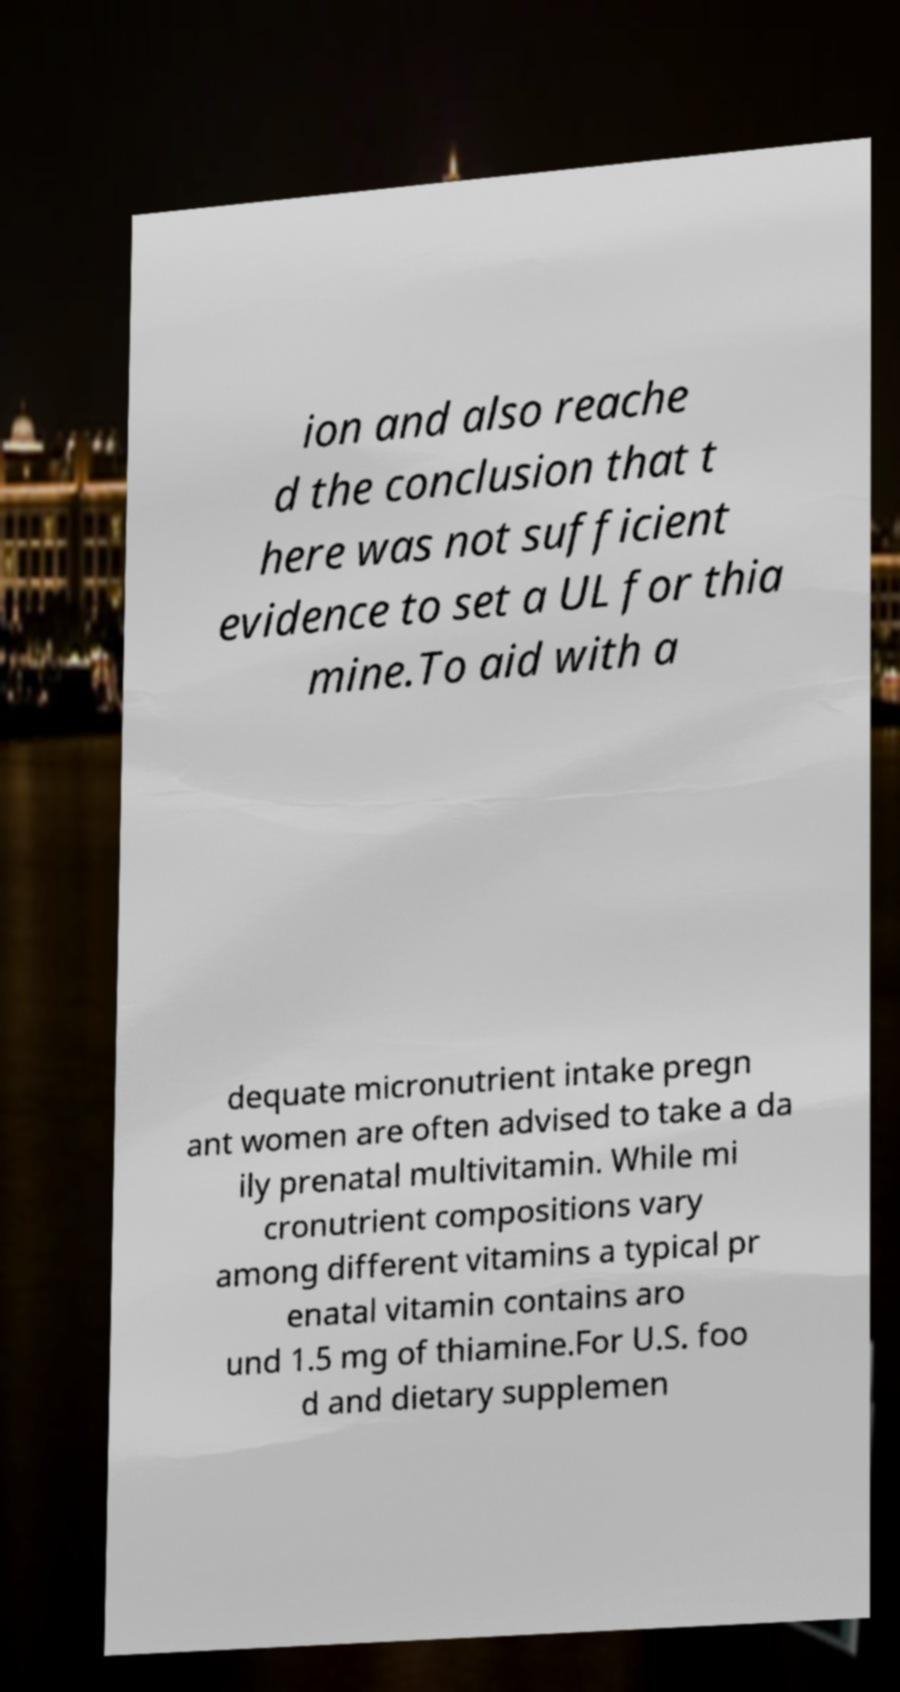For documentation purposes, I need the text within this image transcribed. Could you provide that? ion and also reache d the conclusion that t here was not sufficient evidence to set a UL for thia mine.To aid with a dequate micronutrient intake pregn ant women are often advised to take a da ily prenatal multivitamin. While mi cronutrient compositions vary among different vitamins a typical pr enatal vitamin contains aro und 1.5 mg of thiamine.For U.S. foo d and dietary supplemen 